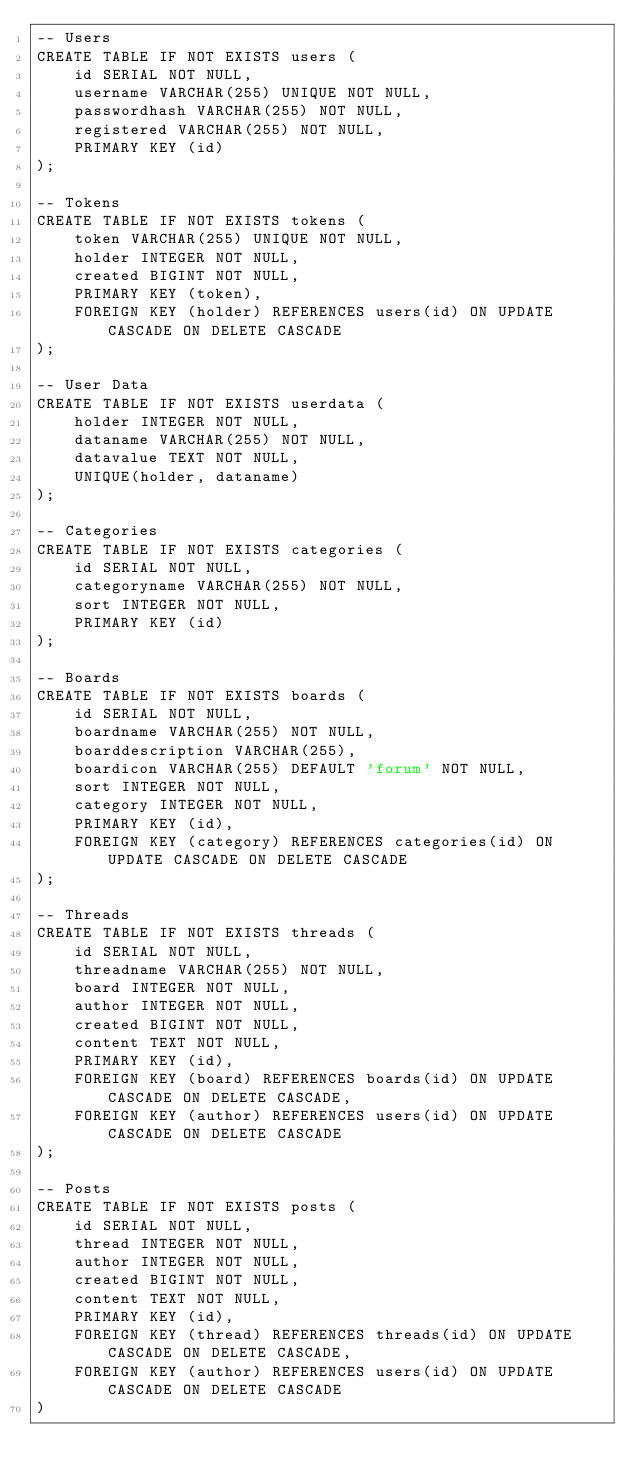<code> <loc_0><loc_0><loc_500><loc_500><_SQL_>-- Users
CREATE TABLE IF NOT EXISTS users (
    id SERIAL NOT NULL,
    username VARCHAR(255) UNIQUE NOT NULL,
    passwordhash VARCHAR(255) NOT NULL,
    registered VARCHAR(255) NOT NULL,
    PRIMARY KEY (id)
);

-- Tokens
CREATE TABLE IF NOT EXISTS tokens (
    token VARCHAR(255) UNIQUE NOT NULL,
    holder INTEGER NOT NULL,
    created BIGINT NOT NULL,
    PRIMARY KEY (token),
    FOREIGN KEY (holder) REFERENCES users(id) ON UPDATE CASCADE ON DELETE CASCADE
);

-- User Data
CREATE TABLE IF NOT EXISTS userdata (
    holder INTEGER NOT NULL,
    dataname VARCHAR(255) NOT NULL,
    datavalue TEXT NOT NULL,
    UNIQUE(holder, dataname)
);

-- Categories
CREATE TABLE IF NOT EXISTS categories (
    id SERIAL NOT NULL,
    categoryname VARCHAR(255) NOT NULL,
    sort INTEGER NOT NULL,
    PRIMARY KEY (id)
);

-- Boards
CREATE TABLE IF NOT EXISTS boards (
    id SERIAL NOT NULL,
    boardname VARCHAR(255) NOT NULL,
    boarddescription VARCHAR(255),
    boardicon VARCHAR(255) DEFAULT 'forum' NOT NULL,
    sort INTEGER NOT NULL,
    category INTEGER NOT NULL,
    PRIMARY KEY (id),
    FOREIGN KEY (category) REFERENCES categories(id) ON UPDATE CASCADE ON DELETE CASCADE
);

-- Threads
CREATE TABLE IF NOT EXISTS threads (
    id SERIAL NOT NULL,
    threadname VARCHAR(255) NOT NULL,
    board INTEGER NOT NULL,
    author INTEGER NOT NULL,
    created BIGINT NOT NULL,
    content TEXT NOT NULL,
    PRIMARY KEY (id),
    FOREIGN KEY (board) REFERENCES boards(id) ON UPDATE CASCADE ON DELETE CASCADE,
    FOREIGN KEY (author) REFERENCES users(id) ON UPDATE CASCADE ON DELETE CASCADE
);

-- Posts
CREATE TABLE IF NOT EXISTS posts (
    id SERIAL NOT NULL,
    thread INTEGER NOT NULL,
    author INTEGER NOT NULL,
    created BIGINT NOT NULL,
    content TEXT NOT NULL,
    PRIMARY KEY (id),
    FOREIGN KEY (thread) REFERENCES threads(id) ON UPDATE CASCADE ON DELETE CASCADE,
    FOREIGN KEY (author) REFERENCES users(id) ON UPDATE CASCADE ON DELETE CASCADE
)
</code> 